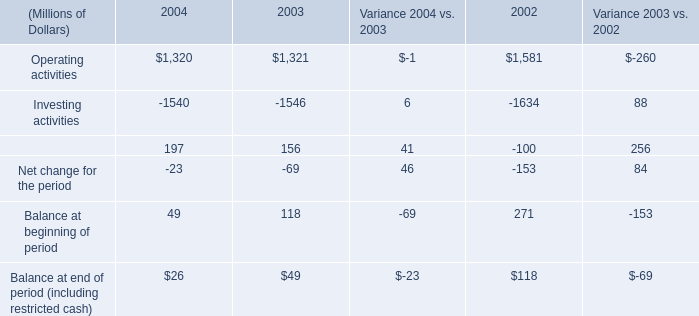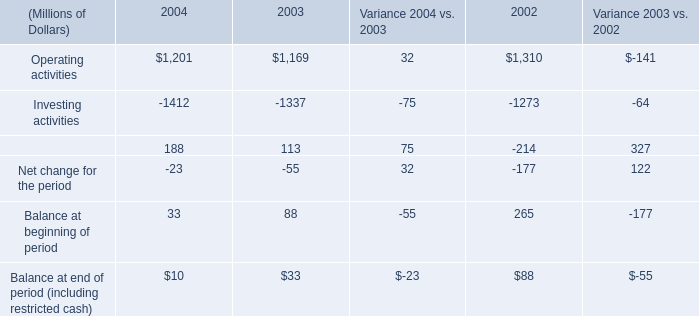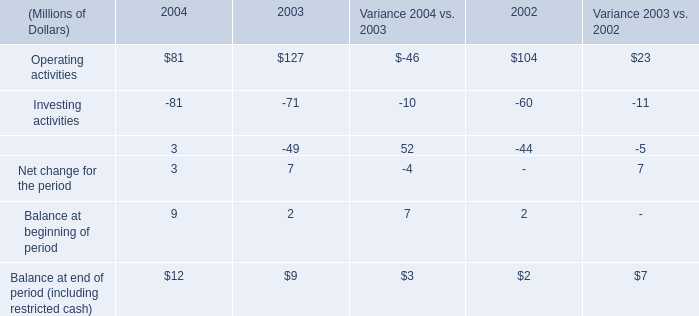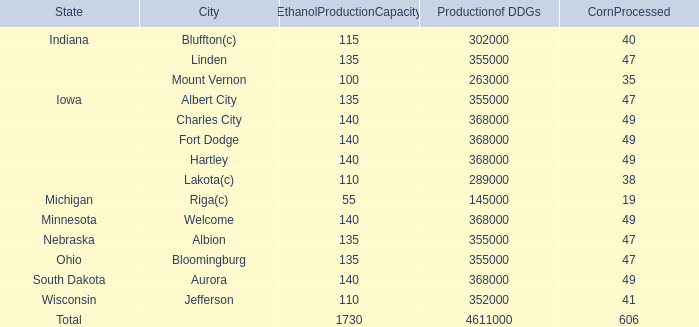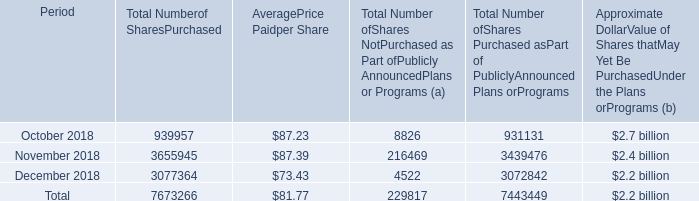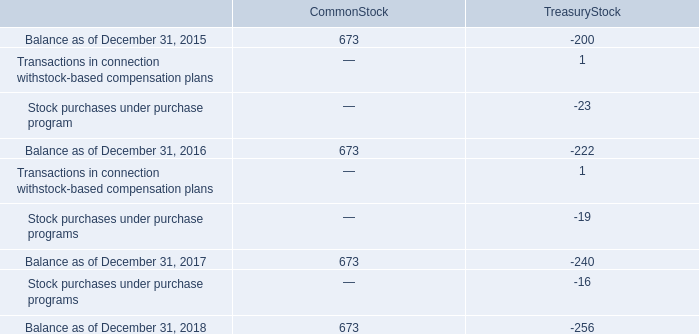What is the sum of Investing activities of 2002, and Nebraska of Productionof DDGs ? 
Computations: (1634.0 + 355000.0)
Answer: 356634.0. 